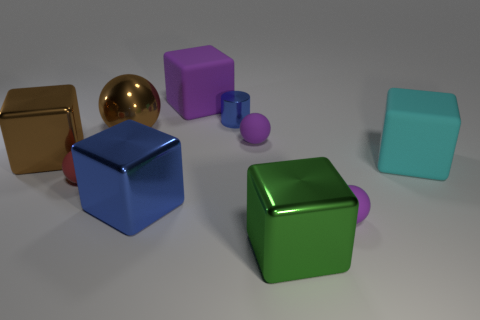Subtract 1 blocks. How many blocks are left? 4 Subtract all brown cubes. How many cubes are left? 4 Subtract all rubber balls. How many balls are left? 1 Subtract all blue cubes. Subtract all purple balls. How many cubes are left? 4 Subtract all cylinders. How many objects are left? 9 Subtract 1 blue cubes. How many objects are left? 9 Subtract all purple spheres. Subtract all big green metallic blocks. How many objects are left? 7 Add 6 large brown metal balls. How many large brown metal balls are left? 7 Add 3 small blue metal objects. How many small blue metal objects exist? 4 